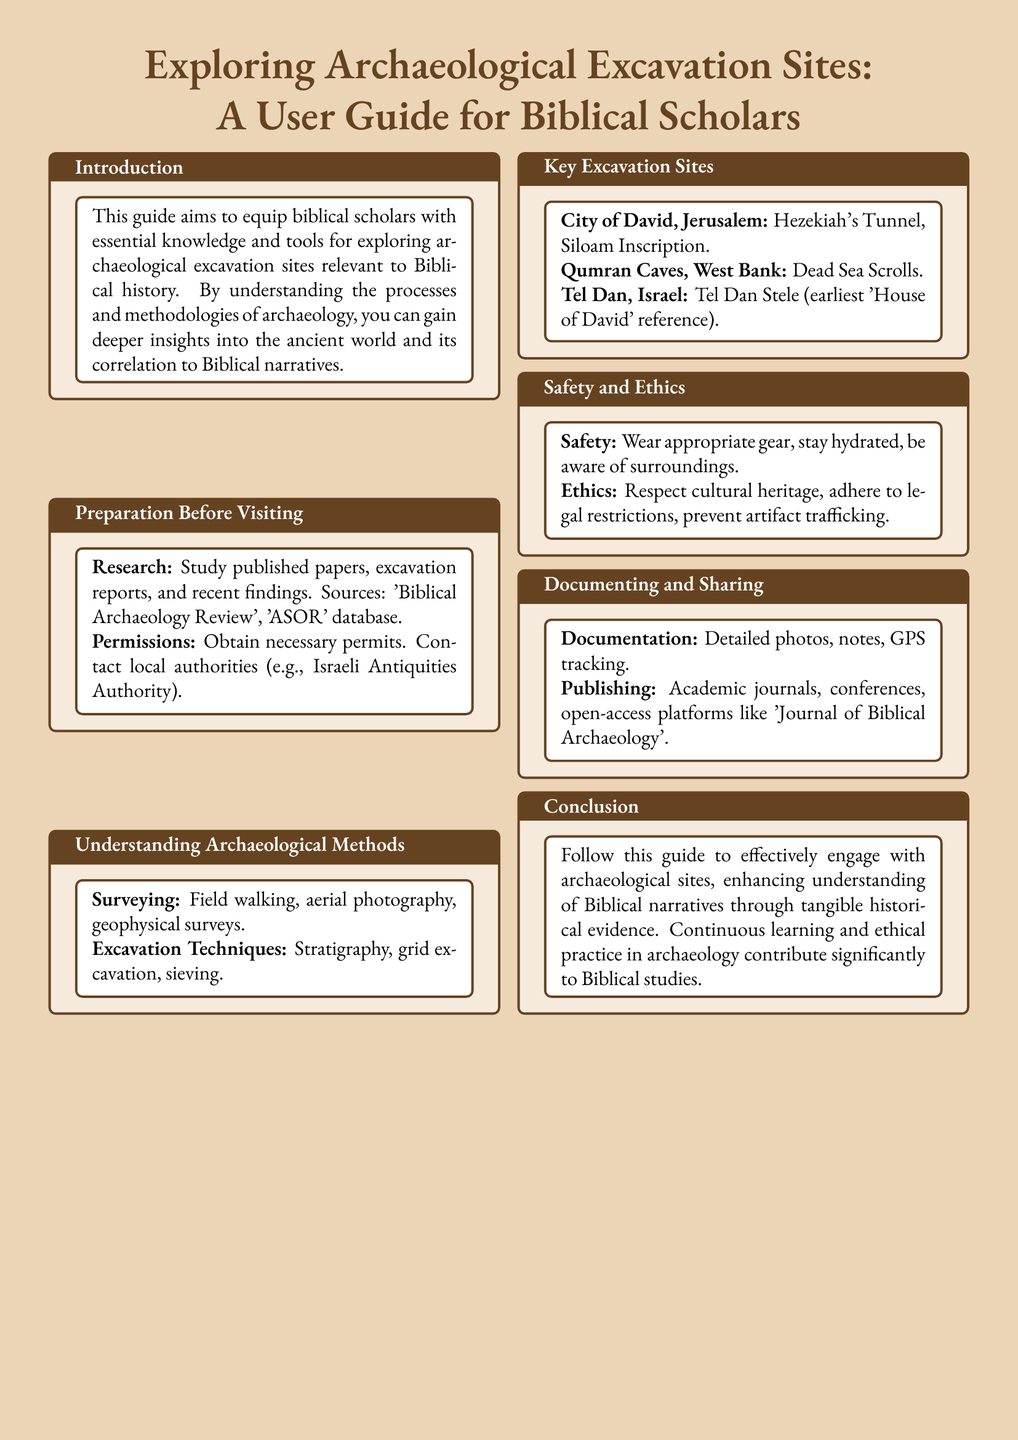What is the title of the guide? The title appears at the top of the document and is "Exploring Archaeological Excavation Sites: A User Guide for Biblical Scholars."
Answer: Exploring Archaeological Excavation Sites: A User Guide for Biblical Scholars What should be studied before visiting an excavation site? The guide mentions that one should study published papers, excavation reports, and recent findings.
Answer: Published papers, excavation reports, and recent findings Which site is associated with the Dead Sea Scrolls? The document lists the Qumran Caves in the West Bank as the site where the Dead Sea Scrolls were discovered.
Answer: Qumran Caves What is one excavation technique mentioned in the guide? The guide lists stratigraphy, which is a method of excavation.
Answer: Stratigraphy What type of gear should be worn for safety? The guide advises wearing appropriate gear to ensure safety while exploring sites.
Answer: Appropriate gear What is one example of a publication platform mentioned for sharing research? The guide mentions the "Journal of Biblical Archaeology" as an open-access platform for publishing research.
Answer: Journal of Biblical Archaeology What is emphasized as important in the Ethics section? The guide stresses the importance of respecting cultural heritage in archaeological practice.
Answer: Respect cultural heritage How should documentation be conducted according to the guide? The guide states that documentation should include detailed photos, notes, and GPS tracking.
Answer: Detailed photos, notes, GPS tracking 